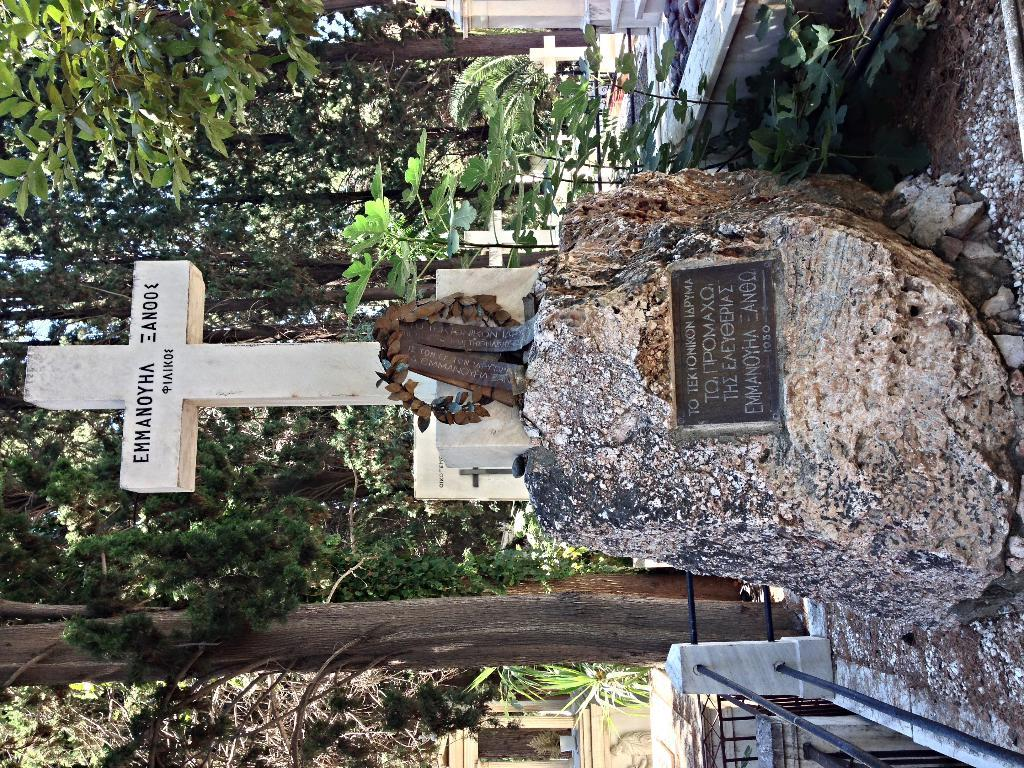What object is the main focus of the image? There is a stone in the image. What is depicted on the stone? There is a cross symbol on the stone. What can be seen in the background of the image? There are trees in the background of the image. What might be the location or setting of the image? The image appears to be of a graveyard. How many islands can be seen in the image? There are no islands present in the image. What type of crook is visible in the image? There is no crook present in the image. 